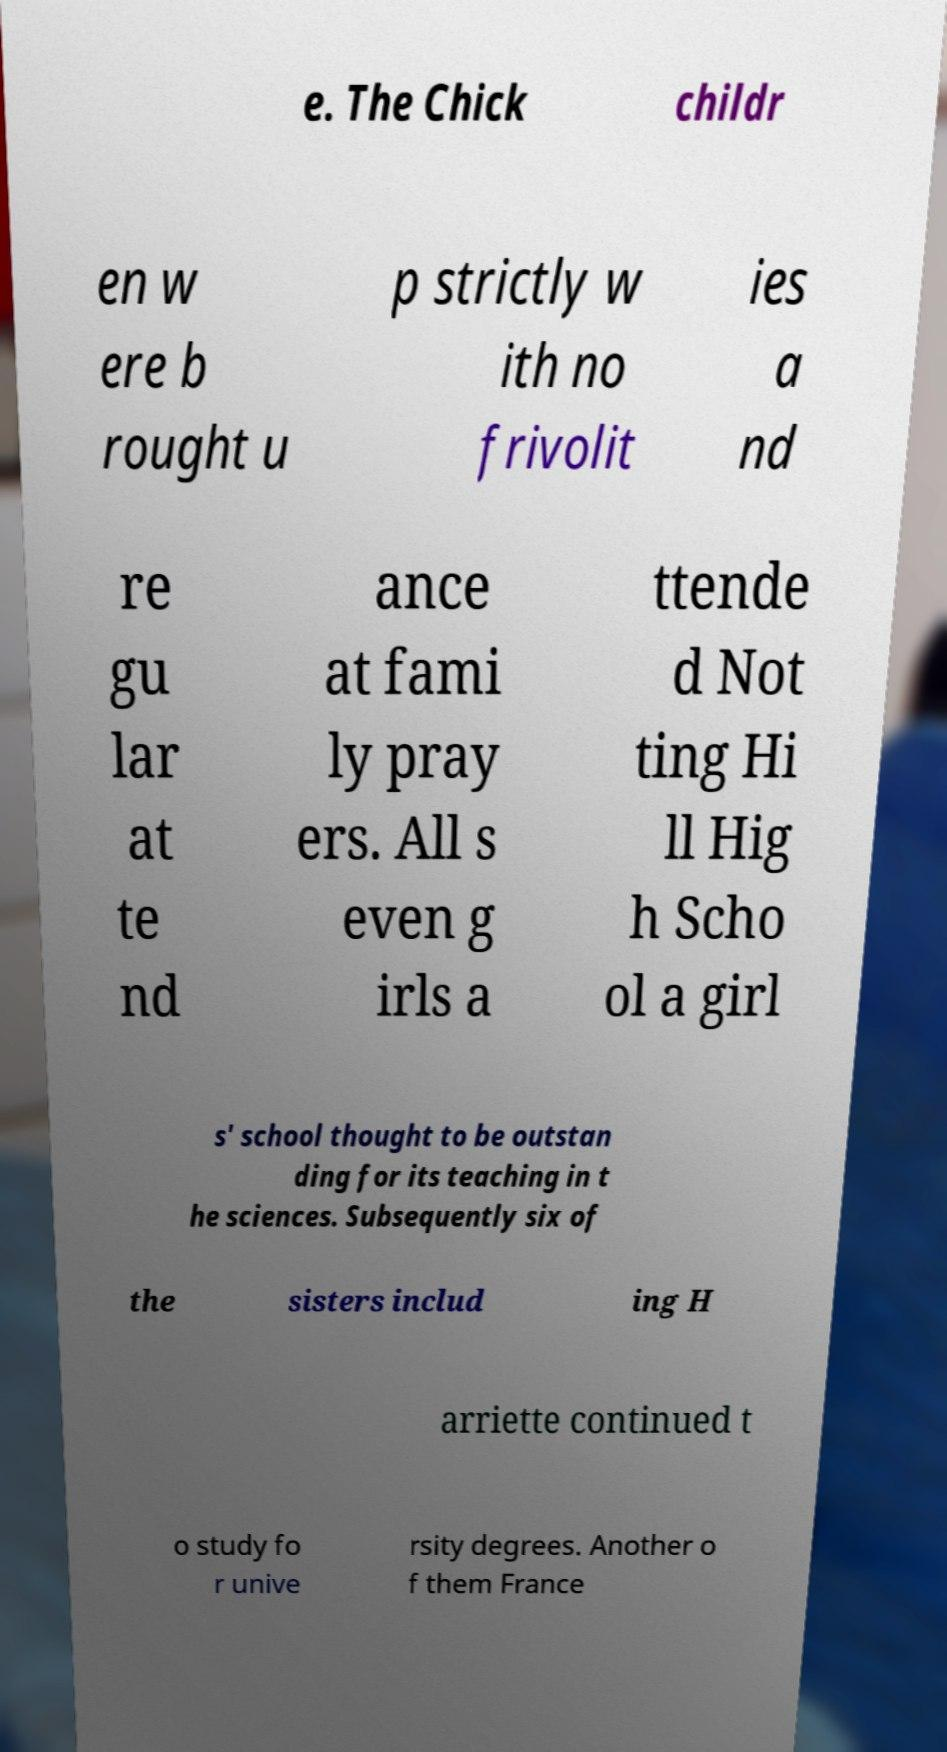Can you read and provide the text displayed in the image?This photo seems to have some interesting text. Can you extract and type it out for me? e. The Chick childr en w ere b rought u p strictly w ith no frivolit ies a nd re gu lar at te nd ance at fami ly pray ers. All s even g irls a ttende d Not ting Hi ll Hig h Scho ol a girl s' school thought to be outstan ding for its teaching in t he sciences. Subsequently six of the sisters includ ing H arriette continued t o study fo r unive rsity degrees. Another o f them France 